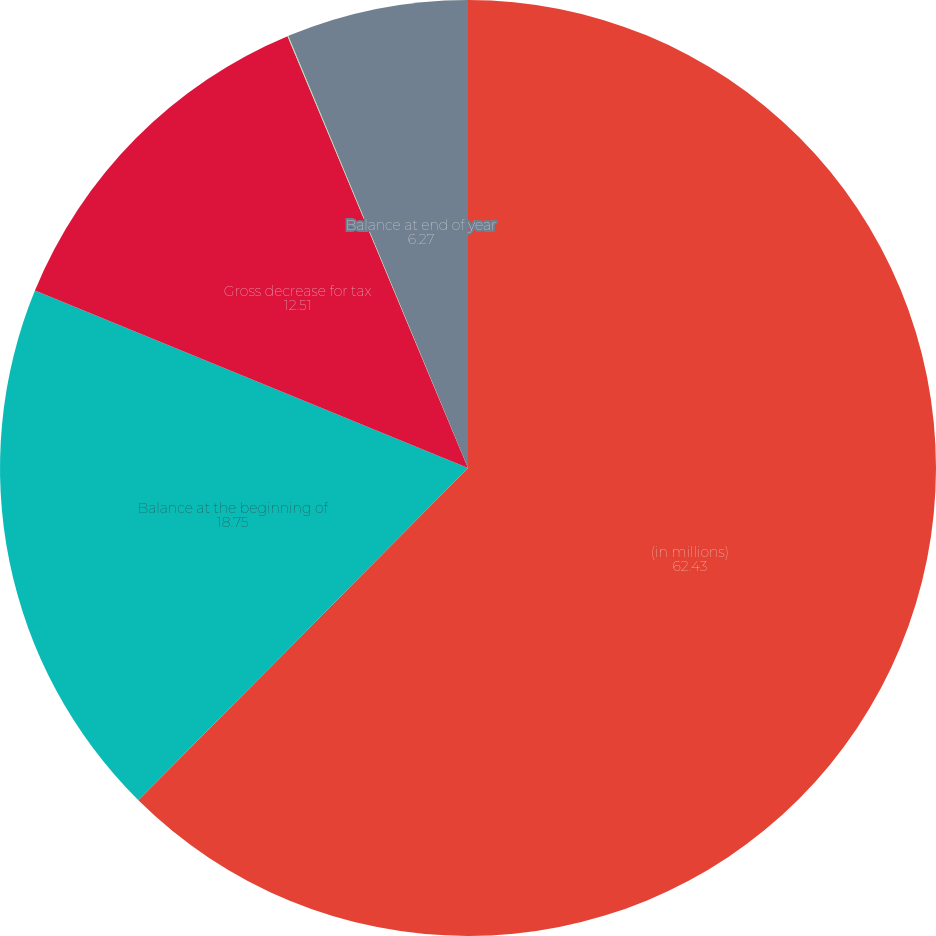Convert chart to OTSL. <chart><loc_0><loc_0><loc_500><loc_500><pie_chart><fcel>(in millions)<fcel>Balance at the beginning of<fcel>Gross decrease for tax<fcel>Decreases for tax positions as<fcel>Balance at end of year<nl><fcel>62.43%<fcel>18.75%<fcel>12.51%<fcel>0.03%<fcel>6.27%<nl></chart> 